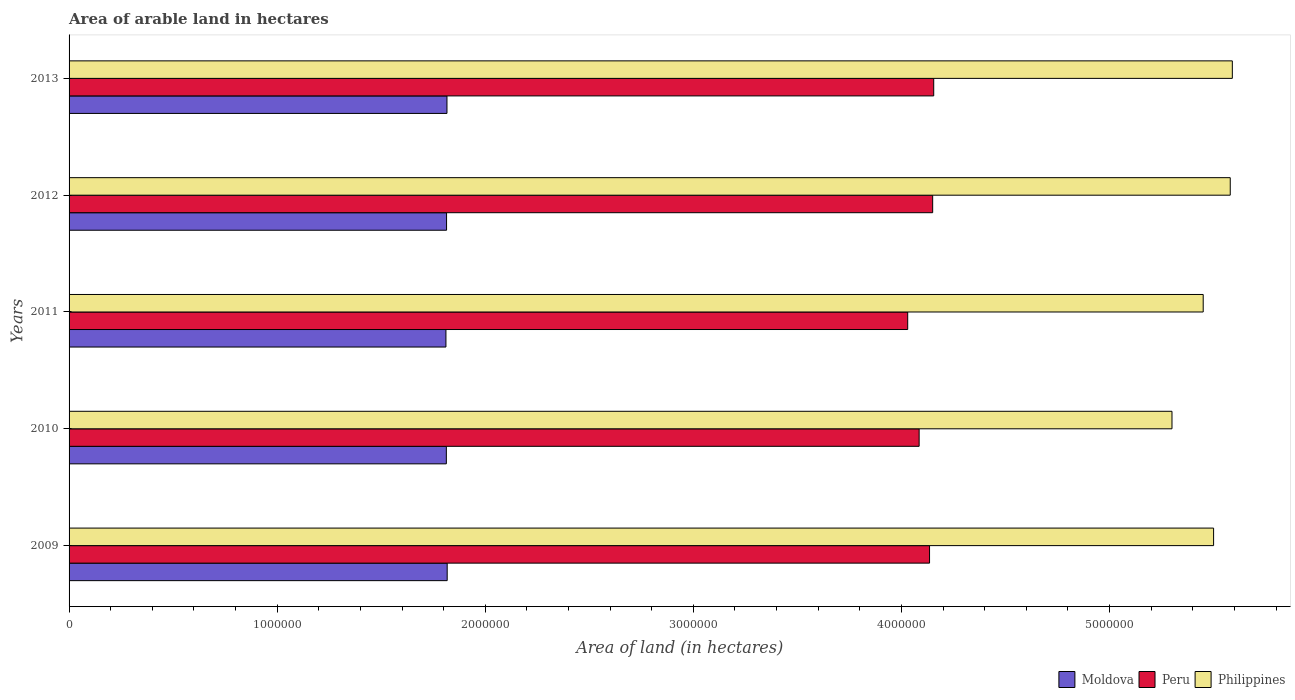How many groups of bars are there?
Provide a short and direct response. 5. Are the number of bars per tick equal to the number of legend labels?
Keep it short and to the point. Yes. In how many cases, is the number of bars for a given year not equal to the number of legend labels?
Ensure brevity in your answer.  0. What is the total arable land in Moldova in 2013?
Your response must be concise. 1.82e+06. Across all years, what is the maximum total arable land in Peru?
Your response must be concise. 4.16e+06. Across all years, what is the minimum total arable land in Philippines?
Give a very brief answer. 5.30e+06. What is the total total arable land in Moldova in the graph?
Provide a succinct answer. 9.07e+06. What is the difference between the total arable land in Moldova in 2011 and that in 2012?
Ensure brevity in your answer.  -3000. What is the difference between the total arable land in Peru in 2011 and the total arable land in Philippines in 2012?
Your response must be concise. -1.55e+06. What is the average total arable land in Moldova per year?
Keep it short and to the point. 1.81e+06. In the year 2010, what is the difference between the total arable land in Moldova and total arable land in Peru?
Provide a short and direct response. -2.27e+06. What is the ratio of the total arable land in Peru in 2009 to that in 2010?
Make the answer very short. 1.01. Is the total arable land in Moldova in 2011 less than that in 2013?
Keep it short and to the point. Yes. What is the difference between the highest and the lowest total arable land in Peru?
Your response must be concise. 1.25e+05. In how many years, is the total arable land in Peru greater than the average total arable land in Peru taken over all years?
Keep it short and to the point. 3. Is the sum of the total arable land in Peru in 2010 and 2012 greater than the maximum total arable land in Moldova across all years?
Offer a terse response. Yes. What does the 1st bar from the top in 2013 represents?
Offer a terse response. Philippines. Is it the case that in every year, the sum of the total arable land in Moldova and total arable land in Philippines is greater than the total arable land in Peru?
Give a very brief answer. Yes. How many years are there in the graph?
Make the answer very short. 5. Where does the legend appear in the graph?
Your answer should be compact. Bottom right. What is the title of the graph?
Keep it short and to the point. Area of arable land in hectares. What is the label or title of the X-axis?
Your answer should be compact. Area of land (in hectares). What is the Area of land (in hectares) in Moldova in 2009?
Offer a terse response. 1.82e+06. What is the Area of land (in hectares) in Peru in 2009?
Offer a very short reply. 4.14e+06. What is the Area of land (in hectares) of Philippines in 2009?
Keep it short and to the point. 5.50e+06. What is the Area of land (in hectares) in Moldova in 2010?
Provide a short and direct response. 1.81e+06. What is the Area of land (in hectares) of Peru in 2010?
Ensure brevity in your answer.  4.08e+06. What is the Area of land (in hectares) in Philippines in 2010?
Offer a very short reply. 5.30e+06. What is the Area of land (in hectares) in Moldova in 2011?
Offer a terse response. 1.81e+06. What is the Area of land (in hectares) in Peru in 2011?
Your answer should be very brief. 4.03e+06. What is the Area of land (in hectares) in Philippines in 2011?
Provide a short and direct response. 5.45e+06. What is the Area of land (in hectares) of Moldova in 2012?
Provide a succinct answer. 1.81e+06. What is the Area of land (in hectares) in Peru in 2012?
Offer a terse response. 4.15e+06. What is the Area of land (in hectares) of Philippines in 2012?
Your response must be concise. 5.58e+06. What is the Area of land (in hectares) of Moldova in 2013?
Offer a very short reply. 1.82e+06. What is the Area of land (in hectares) in Peru in 2013?
Provide a succinct answer. 4.16e+06. What is the Area of land (in hectares) of Philippines in 2013?
Your answer should be compact. 5.59e+06. Across all years, what is the maximum Area of land (in hectares) in Moldova?
Offer a terse response. 1.82e+06. Across all years, what is the maximum Area of land (in hectares) of Peru?
Your answer should be very brief. 4.16e+06. Across all years, what is the maximum Area of land (in hectares) in Philippines?
Make the answer very short. 5.59e+06. Across all years, what is the minimum Area of land (in hectares) of Moldova?
Your answer should be compact. 1.81e+06. Across all years, what is the minimum Area of land (in hectares) in Peru?
Your response must be concise. 4.03e+06. Across all years, what is the minimum Area of land (in hectares) of Philippines?
Keep it short and to the point. 5.30e+06. What is the total Area of land (in hectares) of Moldova in the graph?
Your answer should be very brief. 9.07e+06. What is the total Area of land (in hectares) in Peru in the graph?
Make the answer very short. 2.06e+07. What is the total Area of land (in hectares) in Philippines in the graph?
Keep it short and to the point. 2.74e+07. What is the difference between the Area of land (in hectares) of Moldova in 2009 and that in 2010?
Your answer should be very brief. 4000. What is the difference between the Area of land (in hectares) of Moldova in 2009 and that in 2011?
Keep it short and to the point. 6000. What is the difference between the Area of land (in hectares) in Peru in 2009 and that in 2011?
Your answer should be compact. 1.05e+05. What is the difference between the Area of land (in hectares) in Philippines in 2009 and that in 2011?
Offer a very short reply. 5.00e+04. What is the difference between the Area of land (in hectares) of Moldova in 2009 and that in 2012?
Give a very brief answer. 3000. What is the difference between the Area of land (in hectares) in Peru in 2009 and that in 2012?
Keep it short and to the point. -1.50e+04. What is the difference between the Area of land (in hectares) of Peru in 2009 and that in 2013?
Provide a short and direct response. -2.00e+04. What is the difference between the Area of land (in hectares) in Philippines in 2009 and that in 2013?
Give a very brief answer. -9.00e+04. What is the difference between the Area of land (in hectares) in Moldova in 2010 and that in 2011?
Your answer should be compact. 2000. What is the difference between the Area of land (in hectares) in Peru in 2010 and that in 2011?
Provide a short and direct response. 5.50e+04. What is the difference between the Area of land (in hectares) in Moldova in 2010 and that in 2012?
Keep it short and to the point. -1000. What is the difference between the Area of land (in hectares) in Peru in 2010 and that in 2012?
Provide a succinct answer. -6.50e+04. What is the difference between the Area of land (in hectares) of Philippines in 2010 and that in 2012?
Ensure brevity in your answer.  -2.80e+05. What is the difference between the Area of land (in hectares) in Moldova in 2010 and that in 2013?
Make the answer very short. -3000. What is the difference between the Area of land (in hectares) of Peru in 2010 and that in 2013?
Provide a short and direct response. -7.00e+04. What is the difference between the Area of land (in hectares) of Philippines in 2010 and that in 2013?
Offer a very short reply. -2.90e+05. What is the difference between the Area of land (in hectares) of Moldova in 2011 and that in 2012?
Give a very brief answer. -3000. What is the difference between the Area of land (in hectares) in Philippines in 2011 and that in 2012?
Provide a short and direct response. -1.30e+05. What is the difference between the Area of land (in hectares) of Moldova in 2011 and that in 2013?
Ensure brevity in your answer.  -5000. What is the difference between the Area of land (in hectares) in Peru in 2011 and that in 2013?
Give a very brief answer. -1.25e+05. What is the difference between the Area of land (in hectares) of Philippines in 2011 and that in 2013?
Your response must be concise. -1.40e+05. What is the difference between the Area of land (in hectares) in Moldova in 2012 and that in 2013?
Ensure brevity in your answer.  -2000. What is the difference between the Area of land (in hectares) in Peru in 2012 and that in 2013?
Give a very brief answer. -5000. What is the difference between the Area of land (in hectares) of Moldova in 2009 and the Area of land (in hectares) of Peru in 2010?
Provide a short and direct response. -2.27e+06. What is the difference between the Area of land (in hectares) in Moldova in 2009 and the Area of land (in hectares) in Philippines in 2010?
Make the answer very short. -3.48e+06. What is the difference between the Area of land (in hectares) in Peru in 2009 and the Area of land (in hectares) in Philippines in 2010?
Give a very brief answer. -1.16e+06. What is the difference between the Area of land (in hectares) of Moldova in 2009 and the Area of land (in hectares) of Peru in 2011?
Provide a succinct answer. -2.21e+06. What is the difference between the Area of land (in hectares) in Moldova in 2009 and the Area of land (in hectares) in Philippines in 2011?
Make the answer very short. -3.63e+06. What is the difference between the Area of land (in hectares) of Peru in 2009 and the Area of land (in hectares) of Philippines in 2011?
Offer a terse response. -1.32e+06. What is the difference between the Area of land (in hectares) in Moldova in 2009 and the Area of land (in hectares) in Peru in 2012?
Ensure brevity in your answer.  -2.33e+06. What is the difference between the Area of land (in hectares) in Moldova in 2009 and the Area of land (in hectares) in Philippines in 2012?
Ensure brevity in your answer.  -3.76e+06. What is the difference between the Area of land (in hectares) of Peru in 2009 and the Area of land (in hectares) of Philippines in 2012?
Give a very brief answer. -1.44e+06. What is the difference between the Area of land (in hectares) in Moldova in 2009 and the Area of land (in hectares) in Peru in 2013?
Ensure brevity in your answer.  -2.34e+06. What is the difference between the Area of land (in hectares) in Moldova in 2009 and the Area of land (in hectares) in Philippines in 2013?
Give a very brief answer. -3.77e+06. What is the difference between the Area of land (in hectares) of Peru in 2009 and the Area of land (in hectares) of Philippines in 2013?
Ensure brevity in your answer.  -1.46e+06. What is the difference between the Area of land (in hectares) in Moldova in 2010 and the Area of land (in hectares) in Peru in 2011?
Your answer should be compact. -2.22e+06. What is the difference between the Area of land (in hectares) of Moldova in 2010 and the Area of land (in hectares) of Philippines in 2011?
Give a very brief answer. -3.64e+06. What is the difference between the Area of land (in hectares) in Peru in 2010 and the Area of land (in hectares) in Philippines in 2011?
Make the answer very short. -1.36e+06. What is the difference between the Area of land (in hectares) in Moldova in 2010 and the Area of land (in hectares) in Peru in 2012?
Make the answer very short. -2.34e+06. What is the difference between the Area of land (in hectares) in Moldova in 2010 and the Area of land (in hectares) in Philippines in 2012?
Give a very brief answer. -3.77e+06. What is the difference between the Area of land (in hectares) of Peru in 2010 and the Area of land (in hectares) of Philippines in 2012?
Give a very brief answer. -1.50e+06. What is the difference between the Area of land (in hectares) in Moldova in 2010 and the Area of land (in hectares) in Peru in 2013?
Ensure brevity in your answer.  -2.34e+06. What is the difference between the Area of land (in hectares) in Moldova in 2010 and the Area of land (in hectares) in Philippines in 2013?
Your answer should be compact. -3.78e+06. What is the difference between the Area of land (in hectares) of Peru in 2010 and the Area of land (in hectares) of Philippines in 2013?
Keep it short and to the point. -1.50e+06. What is the difference between the Area of land (in hectares) of Moldova in 2011 and the Area of land (in hectares) of Peru in 2012?
Provide a short and direct response. -2.34e+06. What is the difference between the Area of land (in hectares) in Moldova in 2011 and the Area of land (in hectares) in Philippines in 2012?
Offer a very short reply. -3.77e+06. What is the difference between the Area of land (in hectares) of Peru in 2011 and the Area of land (in hectares) of Philippines in 2012?
Make the answer very short. -1.55e+06. What is the difference between the Area of land (in hectares) of Moldova in 2011 and the Area of land (in hectares) of Peru in 2013?
Make the answer very short. -2.34e+06. What is the difference between the Area of land (in hectares) in Moldova in 2011 and the Area of land (in hectares) in Philippines in 2013?
Offer a very short reply. -3.78e+06. What is the difference between the Area of land (in hectares) of Peru in 2011 and the Area of land (in hectares) of Philippines in 2013?
Offer a very short reply. -1.56e+06. What is the difference between the Area of land (in hectares) of Moldova in 2012 and the Area of land (in hectares) of Peru in 2013?
Offer a terse response. -2.34e+06. What is the difference between the Area of land (in hectares) of Moldova in 2012 and the Area of land (in hectares) of Philippines in 2013?
Give a very brief answer. -3.78e+06. What is the difference between the Area of land (in hectares) in Peru in 2012 and the Area of land (in hectares) in Philippines in 2013?
Your answer should be very brief. -1.44e+06. What is the average Area of land (in hectares) in Moldova per year?
Offer a very short reply. 1.81e+06. What is the average Area of land (in hectares) of Peru per year?
Provide a succinct answer. 4.11e+06. What is the average Area of land (in hectares) of Philippines per year?
Ensure brevity in your answer.  5.48e+06. In the year 2009, what is the difference between the Area of land (in hectares) in Moldova and Area of land (in hectares) in Peru?
Your answer should be very brief. -2.32e+06. In the year 2009, what is the difference between the Area of land (in hectares) of Moldova and Area of land (in hectares) of Philippines?
Provide a short and direct response. -3.68e+06. In the year 2009, what is the difference between the Area of land (in hectares) of Peru and Area of land (in hectares) of Philippines?
Your response must be concise. -1.36e+06. In the year 2010, what is the difference between the Area of land (in hectares) of Moldova and Area of land (in hectares) of Peru?
Make the answer very short. -2.27e+06. In the year 2010, what is the difference between the Area of land (in hectares) in Moldova and Area of land (in hectares) in Philippines?
Ensure brevity in your answer.  -3.49e+06. In the year 2010, what is the difference between the Area of land (in hectares) of Peru and Area of land (in hectares) of Philippines?
Your answer should be compact. -1.22e+06. In the year 2011, what is the difference between the Area of land (in hectares) of Moldova and Area of land (in hectares) of Peru?
Offer a terse response. -2.22e+06. In the year 2011, what is the difference between the Area of land (in hectares) of Moldova and Area of land (in hectares) of Philippines?
Provide a succinct answer. -3.64e+06. In the year 2011, what is the difference between the Area of land (in hectares) of Peru and Area of land (in hectares) of Philippines?
Offer a very short reply. -1.42e+06. In the year 2012, what is the difference between the Area of land (in hectares) of Moldova and Area of land (in hectares) of Peru?
Your answer should be very brief. -2.34e+06. In the year 2012, what is the difference between the Area of land (in hectares) in Moldova and Area of land (in hectares) in Philippines?
Ensure brevity in your answer.  -3.77e+06. In the year 2012, what is the difference between the Area of land (in hectares) in Peru and Area of land (in hectares) in Philippines?
Make the answer very short. -1.43e+06. In the year 2013, what is the difference between the Area of land (in hectares) of Moldova and Area of land (in hectares) of Peru?
Ensure brevity in your answer.  -2.34e+06. In the year 2013, what is the difference between the Area of land (in hectares) in Moldova and Area of land (in hectares) in Philippines?
Make the answer very short. -3.77e+06. In the year 2013, what is the difference between the Area of land (in hectares) in Peru and Area of land (in hectares) in Philippines?
Give a very brief answer. -1.44e+06. What is the ratio of the Area of land (in hectares) in Moldova in 2009 to that in 2010?
Your answer should be very brief. 1. What is the ratio of the Area of land (in hectares) of Peru in 2009 to that in 2010?
Offer a very short reply. 1.01. What is the ratio of the Area of land (in hectares) in Philippines in 2009 to that in 2010?
Your answer should be very brief. 1.04. What is the ratio of the Area of land (in hectares) in Peru in 2009 to that in 2011?
Your response must be concise. 1.03. What is the ratio of the Area of land (in hectares) of Philippines in 2009 to that in 2011?
Offer a terse response. 1.01. What is the ratio of the Area of land (in hectares) of Moldova in 2009 to that in 2012?
Ensure brevity in your answer.  1. What is the ratio of the Area of land (in hectares) in Philippines in 2009 to that in 2012?
Ensure brevity in your answer.  0.99. What is the ratio of the Area of land (in hectares) of Peru in 2009 to that in 2013?
Your answer should be very brief. 1. What is the ratio of the Area of land (in hectares) in Philippines in 2009 to that in 2013?
Ensure brevity in your answer.  0.98. What is the ratio of the Area of land (in hectares) in Moldova in 2010 to that in 2011?
Provide a succinct answer. 1. What is the ratio of the Area of land (in hectares) of Peru in 2010 to that in 2011?
Provide a succinct answer. 1.01. What is the ratio of the Area of land (in hectares) in Philippines in 2010 to that in 2011?
Ensure brevity in your answer.  0.97. What is the ratio of the Area of land (in hectares) in Moldova in 2010 to that in 2012?
Offer a terse response. 1. What is the ratio of the Area of land (in hectares) in Peru in 2010 to that in 2012?
Make the answer very short. 0.98. What is the ratio of the Area of land (in hectares) in Philippines in 2010 to that in 2012?
Provide a short and direct response. 0.95. What is the ratio of the Area of land (in hectares) in Moldova in 2010 to that in 2013?
Ensure brevity in your answer.  1. What is the ratio of the Area of land (in hectares) in Peru in 2010 to that in 2013?
Offer a very short reply. 0.98. What is the ratio of the Area of land (in hectares) in Philippines in 2010 to that in 2013?
Provide a succinct answer. 0.95. What is the ratio of the Area of land (in hectares) of Peru in 2011 to that in 2012?
Your answer should be very brief. 0.97. What is the ratio of the Area of land (in hectares) in Philippines in 2011 to that in 2012?
Keep it short and to the point. 0.98. What is the ratio of the Area of land (in hectares) of Peru in 2011 to that in 2013?
Your answer should be very brief. 0.97. What is the ratio of the Area of land (in hectares) in Moldova in 2012 to that in 2013?
Give a very brief answer. 1. What is the ratio of the Area of land (in hectares) in Philippines in 2012 to that in 2013?
Offer a terse response. 1. What is the difference between the highest and the lowest Area of land (in hectares) of Moldova?
Keep it short and to the point. 6000. What is the difference between the highest and the lowest Area of land (in hectares) of Peru?
Your answer should be compact. 1.25e+05. What is the difference between the highest and the lowest Area of land (in hectares) in Philippines?
Make the answer very short. 2.90e+05. 